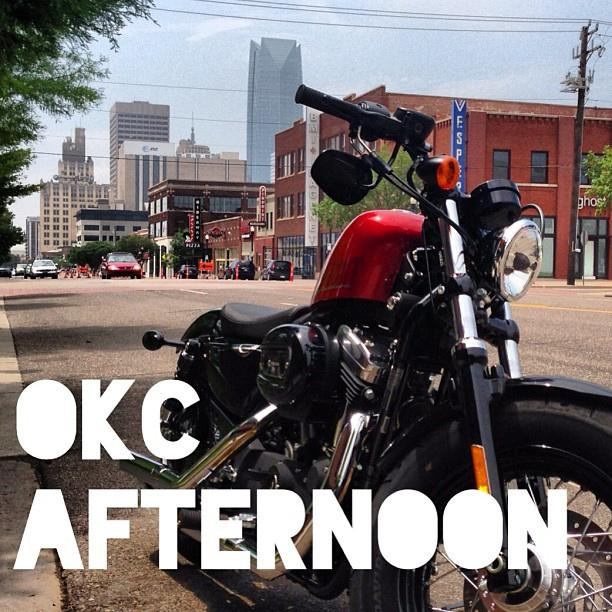What kind of building is the one with the black sign? restaurant 